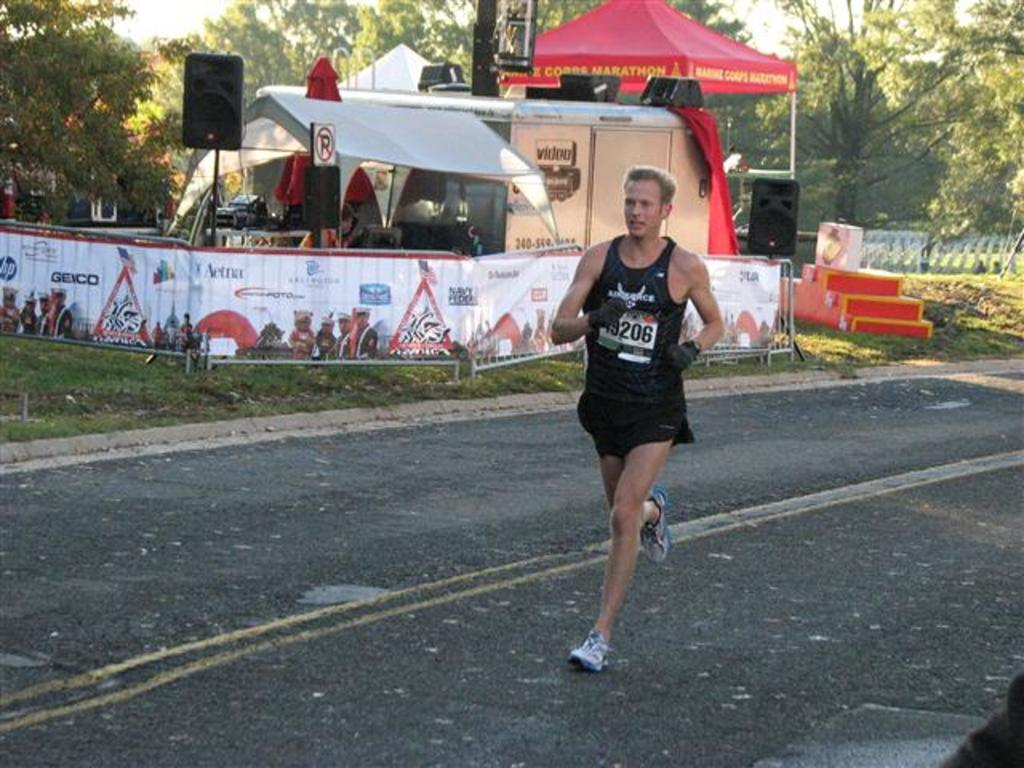What is the man in the image doing? The man is running in the image. What can be seen in the background of the image? There are boards, speakers, trees, and a tent in the background of the image. Can you describe the architectural feature on the right side of the image? There are stairs on the right side of the image. What type of prison can be seen in the image? There is no prison present in the image. What form does the distance take in the image? The concept of "distance" does not apply to the image, as it is a static representation and not a physical space. 